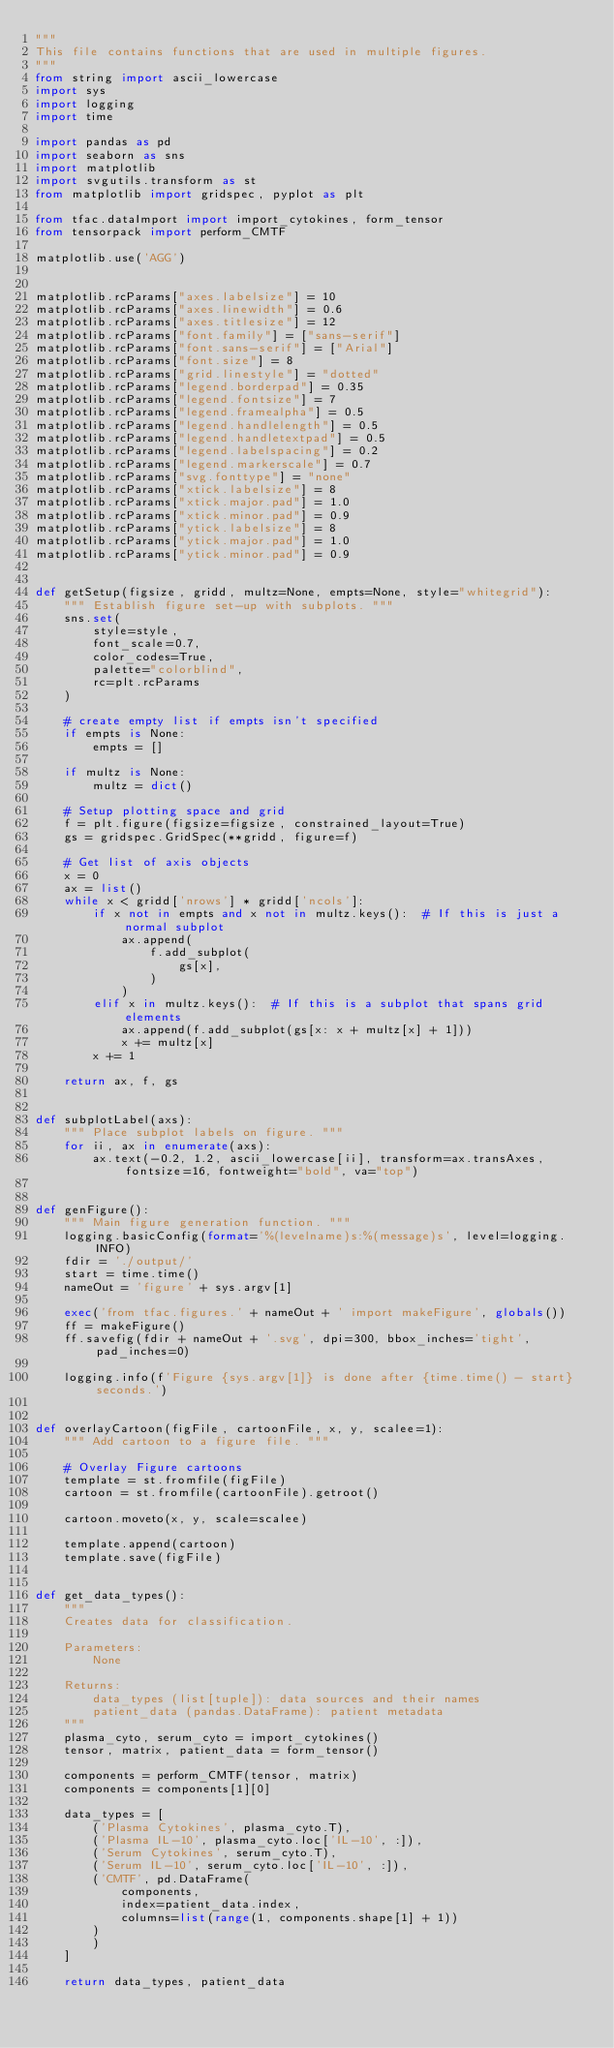Convert code to text. <code><loc_0><loc_0><loc_500><loc_500><_Python_>"""
This file contains functions that are used in multiple figures.
"""
from string import ascii_lowercase
import sys
import logging
import time

import pandas as pd
import seaborn as sns
import matplotlib
import svgutils.transform as st
from matplotlib import gridspec, pyplot as plt

from tfac.dataImport import import_cytokines, form_tensor
from tensorpack import perform_CMTF

matplotlib.use('AGG')


matplotlib.rcParams["axes.labelsize"] = 10
matplotlib.rcParams["axes.linewidth"] = 0.6
matplotlib.rcParams["axes.titlesize"] = 12
matplotlib.rcParams["font.family"] = ["sans-serif"]
matplotlib.rcParams["font.sans-serif"] = ["Arial"]
matplotlib.rcParams["font.size"] = 8
matplotlib.rcParams["grid.linestyle"] = "dotted"
matplotlib.rcParams["legend.borderpad"] = 0.35
matplotlib.rcParams["legend.fontsize"] = 7
matplotlib.rcParams["legend.framealpha"] = 0.5
matplotlib.rcParams["legend.handlelength"] = 0.5
matplotlib.rcParams["legend.handletextpad"] = 0.5
matplotlib.rcParams["legend.labelspacing"] = 0.2
matplotlib.rcParams["legend.markerscale"] = 0.7
matplotlib.rcParams["svg.fonttype"] = "none"
matplotlib.rcParams["xtick.labelsize"] = 8
matplotlib.rcParams["xtick.major.pad"] = 1.0
matplotlib.rcParams["xtick.minor.pad"] = 0.9
matplotlib.rcParams["ytick.labelsize"] = 8
matplotlib.rcParams["ytick.major.pad"] = 1.0
matplotlib.rcParams["ytick.minor.pad"] = 0.9


def getSetup(figsize, gridd, multz=None, empts=None, style="whitegrid"):
    """ Establish figure set-up with subplots. """
    sns.set(
        style=style,
        font_scale=0.7,
        color_codes=True,
        palette="colorblind",
        rc=plt.rcParams
    )

    # create empty list if empts isn't specified
    if empts is None:
        empts = []

    if multz is None:
        multz = dict()

    # Setup plotting space and grid
    f = plt.figure(figsize=figsize, constrained_layout=True)
    gs = gridspec.GridSpec(**gridd, figure=f)

    # Get list of axis objects
    x = 0
    ax = list()
    while x < gridd['nrows'] * gridd['ncols']:
        if x not in empts and x not in multz.keys():  # If this is just a normal subplot
            ax.append(
                f.add_subplot(
                    gs[x],
                )
            )
        elif x in multz.keys():  # If this is a subplot that spans grid elements
            ax.append(f.add_subplot(gs[x: x + multz[x] + 1]))
            x += multz[x]
        x += 1

    return ax, f, gs


def subplotLabel(axs):
    """ Place subplot labels on figure. """
    for ii, ax in enumerate(axs):
        ax.text(-0.2, 1.2, ascii_lowercase[ii], transform=ax.transAxes, fontsize=16, fontweight="bold", va="top")


def genFigure():
    """ Main figure generation function. """
    logging.basicConfig(format='%(levelname)s:%(message)s', level=logging.INFO)
    fdir = './output/'
    start = time.time()
    nameOut = 'figure' + sys.argv[1]

    exec('from tfac.figures.' + nameOut + ' import makeFigure', globals())
    ff = makeFigure()
    ff.savefig(fdir + nameOut + '.svg', dpi=300, bbox_inches='tight', pad_inches=0)

    logging.info(f'Figure {sys.argv[1]} is done after {time.time() - start} seconds.')


def overlayCartoon(figFile, cartoonFile, x, y, scalee=1):
    """ Add cartoon to a figure file. """

    # Overlay Figure cartoons
    template = st.fromfile(figFile)
    cartoon = st.fromfile(cartoonFile).getroot()

    cartoon.moveto(x, y, scale=scalee)

    template.append(cartoon)
    template.save(figFile)


def get_data_types():
    """
    Creates data for classification.

    Parameters:
        None

    Returns:
        data_types (list[tuple]): data sources and their names
        patient_data (pandas.DataFrame): patient metadata
    """
    plasma_cyto, serum_cyto = import_cytokines()
    tensor, matrix, patient_data = form_tensor()

    components = perform_CMTF(tensor, matrix)
    components = components[1][0]

    data_types = [
        ('Plasma Cytokines', plasma_cyto.T),
        ('Plasma IL-10', plasma_cyto.loc['IL-10', :]),
        ('Serum Cytokines', serum_cyto.T),
        ('Serum IL-10', serum_cyto.loc['IL-10', :]),
        ('CMTF', pd.DataFrame(
            components,
            index=patient_data.index,
            columns=list(range(1, components.shape[1] + 1))
        )
        )
    ]

    return data_types, patient_data
</code> 